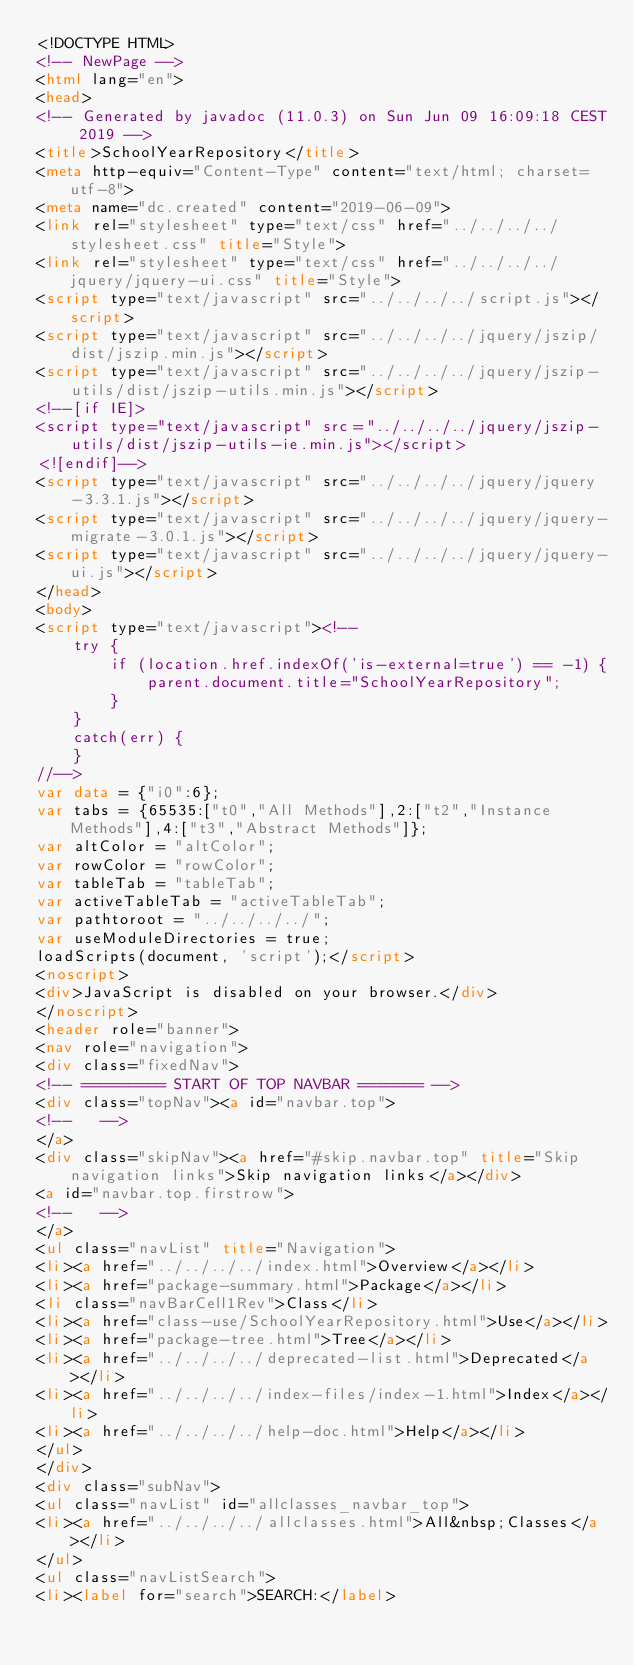Convert code to text. <code><loc_0><loc_0><loc_500><loc_500><_HTML_><!DOCTYPE HTML>
<!-- NewPage -->
<html lang="en">
<head>
<!-- Generated by javadoc (11.0.3) on Sun Jun 09 16:09:18 CEST 2019 -->
<title>SchoolYearRepository</title>
<meta http-equiv="Content-Type" content="text/html; charset=utf-8">
<meta name="dc.created" content="2019-06-09">
<link rel="stylesheet" type="text/css" href="../../../../stylesheet.css" title="Style">
<link rel="stylesheet" type="text/css" href="../../../../jquery/jquery-ui.css" title="Style">
<script type="text/javascript" src="../../../../script.js"></script>
<script type="text/javascript" src="../../../../jquery/jszip/dist/jszip.min.js"></script>
<script type="text/javascript" src="../../../../jquery/jszip-utils/dist/jszip-utils.min.js"></script>
<!--[if IE]>
<script type="text/javascript" src="../../../../jquery/jszip-utils/dist/jszip-utils-ie.min.js"></script>
<![endif]-->
<script type="text/javascript" src="../../../../jquery/jquery-3.3.1.js"></script>
<script type="text/javascript" src="../../../../jquery/jquery-migrate-3.0.1.js"></script>
<script type="text/javascript" src="../../../../jquery/jquery-ui.js"></script>
</head>
<body>
<script type="text/javascript"><!--
    try {
        if (location.href.indexOf('is-external=true') == -1) {
            parent.document.title="SchoolYearRepository";
        }
    }
    catch(err) {
    }
//-->
var data = {"i0":6};
var tabs = {65535:["t0","All Methods"],2:["t2","Instance Methods"],4:["t3","Abstract Methods"]};
var altColor = "altColor";
var rowColor = "rowColor";
var tableTab = "tableTab";
var activeTableTab = "activeTableTab";
var pathtoroot = "../../../../";
var useModuleDirectories = true;
loadScripts(document, 'script');</script>
<noscript>
<div>JavaScript is disabled on your browser.</div>
</noscript>
<header role="banner">
<nav role="navigation">
<div class="fixedNav">
<!-- ========= START OF TOP NAVBAR ======= -->
<div class="topNav"><a id="navbar.top">
<!--   -->
</a>
<div class="skipNav"><a href="#skip.navbar.top" title="Skip navigation links">Skip navigation links</a></div>
<a id="navbar.top.firstrow">
<!--   -->
</a>
<ul class="navList" title="Navigation">
<li><a href="../../../../index.html">Overview</a></li>
<li><a href="package-summary.html">Package</a></li>
<li class="navBarCell1Rev">Class</li>
<li><a href="class-use/SchoolYearRepository.html">Use</a></li>
<li><a href="package-tree.html">Tree</a></li>
<li><a href="../../../../deprecated-list.html">Deprecated</a></li>
<li><a href="../../../../index-files/index-1.html">Index</a></li>
<li><a href="../../../../help-doc.html">Help</a></li>
</ul>
</div>
<div class="subNav">
<ul class="navList" id="allclasses_navbar_top">
<li><a href="../../../../allclasses.html">All&nbsp;Classes</a></li>
</ul>
<ul class="navListSearch">
<li><label for="search">SEARCH:</label></code> 